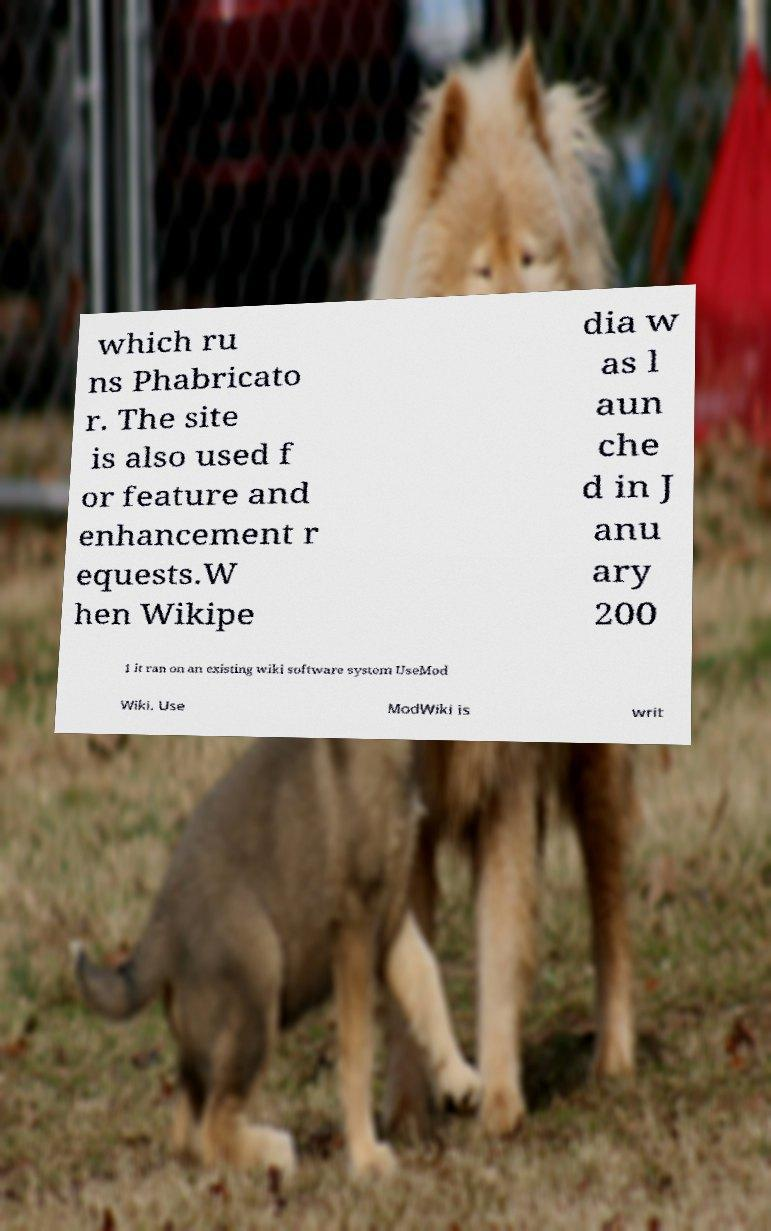Can you accurately transcribe the text from the provided image for me? which ru ns Phabricato r. The site is also used f or feature and enhancement r equests.W hen Wikipe dia w as l aun che d in J anu ary 200 1 it ran on an existing wiki software system UseMod Wiki. Use ModWiki is writ 